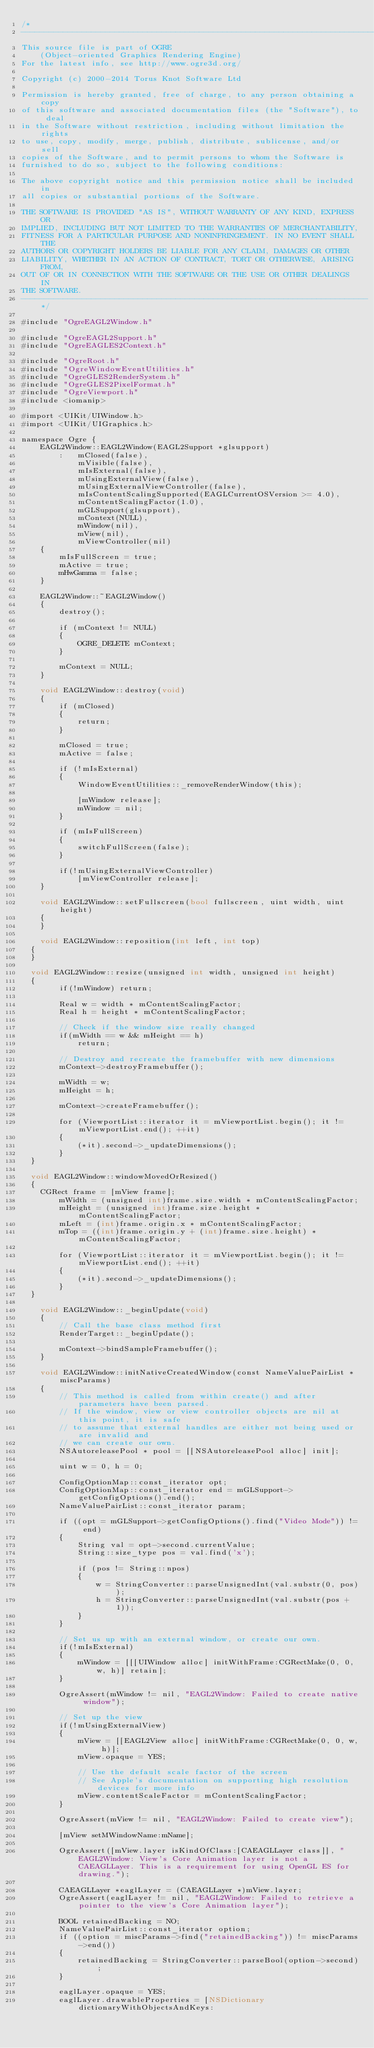Convert code to text. <code><loc_0><loc_0><loc_500><loc_500><_ObjectiveC_>/*
-----------------------------------------------------------------------------
This source file is part of OGRE
    (Object-oriented Graphics Rendering Engine)
For the latest info, see http://www.ogre3d.org/

Copyright (c) 2000-2014 Torus Knot Software Ltd

Permission is hereby granted, free of charge, to any person obtaining a copy
of this software and associated documentation files (the "Software"), to deal
in the Software without restriction, including without limitation the rights
to use, copy, modify, merge, publish, distribute, sublicense, and/or sell
copies of the Software, and to permit persons to whom the Software is
furnished to do so, subject to the following conditions:

The above copyright notice and this permission notice shall be included in
all copies or substantial portions of the Software.

THE SOFTWARE IS PROVIDED "AS IS", WITHOUT WARRANTY OF ANY KIND, EXPRESS OR
IMPLIED, INCLUDING BUT NOT LIMITED TO THE WARRANTIES OF MERCHANTABILITY,
FITNESS FOR A PARTICULAR PURPOSE AND NONINFRINGEMENT. IN NO EVENT SHALL THE
AUTHORS OR COPYRIGHT HOLDERS BE LIABLE FOR ANY CLAIM, DAMAGES OR OTHER
LIABILITY, WHETHER IN AN ACTION OF CONTRACT, TORT OR OTHERWISE, ARISING FROM,
OUT OF OR IN CONNECTION WITH THE SOFTWARE OR THE USE OR OTHER DEALINGS IN
THE SOFTWARE.
--------------------------------------------------------------------------*/

#include "OgreEAGL2Window.h"

#include "OgreEAGL2Support.h"
#include "OgreEAGLES2Context.h"

#include "OgreRoot.h"
#include "OgreWindowEventUtilities.h"
#include "OgreGLES2RenderSystem.h"
#include "OgreGLES2PixelFormat.h"
#include "OgreViewport.h"
#include <iomanip>

#import <UIKit/UIWindow.h>
#import <UIKit/UIGraphics.h>

namespace Ogre {
    EAGL2Window::EAGL2Window(EAGL2Support *glsupport)
        :   mClosed(false),
            mVisible(false),
            mIsExternal(false),
            mUsingExternalView(false),
            mUsingExternalViewController(false),
            mIsContentScalingSupported(EAGLCurrentOSVersion >= 4.0),
            mContentScalingFactor(1.0),
            mGLSupport(glsupport),
            mContext(NULL),
            mWindow(nil),
            mView(nil),
            mViewController(nil)
    {
        mIsFullScreen = true;
        mActive = true;
        mHwGamma = false;
    }

    EAGL2Window::~EAGL2Window()
    {
        destroy();

        if (mContext != NULL)
        {
            OGRE_DELETE mContext;
        }

        mContext = NULL;
    }

    void EAGL2Window::destroy(void)
    {
        if (mClosed)
        {
            return;
        }

        mClosed = true;
        mActive = false;

        if (!mIsExternal)
        {
            WindowEventUtilities::_removeRenderWindow(this);
        
            [mWindow release];
            mWindow = nil;
        }

        if (mIsFullScreen)
        {
            switchFullScreen(false);
        }

        if(!mUsingExternalViewController)
            [mViewController release];
    }

    void EAGL2Window::setFullscreen(bool fullscreen, uint width, uint height)
    {
    }

    void EAGL2Window::reposition(int left, int top)
	{
	}
    
	void EAGL2Window::resize(unsigned int width, unsigned int height)
	{
        if(!mWindow) return;

        Real w = width * mContentScalingFactor;
        Real h = height * mContentScalingFactor;

        // Check if the window size really changed
        if(mWidth == w && mHeight == h)
            return;
        
        // Destroy and recreate the framebuffer with new dimensions 
        mContext->destroyFramebuffer();
        
        mWidth = w;
        mHeight = h;
        
        mContext->createFramebuffer();

        for (ViewportList::iterator it = mViewportList.begin(); it != mViewportList.end(); ++it)
        {
            (*it).second->_updateDimensions();
        }
	}
    
	void EAGL2Window::windowMovedOrResized()
	{
		CGRect frame = [mView frame];
        mWidth = (unsigned int)frame.size.width * mContentScalingFactor;
        mHeight = (unsigned int)frame.size.height * mContentScalingFactor;
        mLeft = (int)frame.origin.x * mContentScalingFactor;
        mTop = ((int)frame.origin.y + (int)frame.size.height) * mContentScalingFactor;

        for (ViewportList::iterator it = mViewportList.begin(); it != mViewportList.end(); ++it)
        {
            (*it).second->_updateDimensions();
        }
	}

    void EAGL2Window::_beginUpdate(void)
    {
        // Call the base class method first
        RenderTarget::_beginUpdate();

        mContext->bindSampleFramebuffer();
    }

    void EAGL2Window::initNativeCreatedWindow(const NameValuePairList *miscParams)
    {
        // This method is called from within create() and after parameters have been parsed.
        // If the window, view or view controller objects are nil at this point, it is safe
        // to assume that external handles are either not being used or are invalid and
        // we can create our own.
        NSAutoreleasePool * pool = [[NSAutoreleasePool alloc] init];
        
        uint w = 0, h = 0;
        
        ConfigOptionMap::const_iterator opt;
        ConfigOptionMap::const_iterator end = mGLSupport->getConfigOptions().end();
        NameValuePairList::const_iterator param;

        if ((opt = mGLSupport->getConfigOptions().find("Video Mode")) != end)
        {
            String val = opt->second.currentValue;
            String::size_type pos = val.find('x');
            
            if (pos != String::npos)
            {
                w = StringConverter::parseUnsignedInt(val.substr(0, pos));
                h = StringConverter::parseUnsignedInt(val.substr(pos + 1));
            }
        }

        // Set us up with an external window, or create our own.
        if(!mIsExternal)
        {
            mWindow = [[[UIWindow alloc] initWithFrame:CGRectMake(0, 0, w, h)] retain];
        }
        
        OgreAssert(mWindow != nil, "EAGL2Window: Failed to create native window");
        
        // Set up the view
        if(!mUsingExternalView)
        {
            mView = [[EAGL2View alloc] initWithFrame:CGRectMake(0, 0, w, h)];
            mView.opaque = YES;

            // Use the default scale factor of the screen
            // See Apple's documentation on supporting high resolution devices for more info
            mView.contentScaleFactor = mContentScalingFactor;
        }
    
        OgreAssert(mView != nil, "EAGL2Window: Failed to create view");
        
        [mView setMWindowName:mName];

        OgreAssert([mView.layer isKindOfClass:[CAEAGLLayer class]], "EAGL2Window: View's Core Animation layer is not a CAEAGLLayer. This is a requirement for using OpenGL ES for drawing.");
        
        CAEAGLLayer *eaglLayer = (CAEAGLLayer *)mView.layer;
        OgreAssert(eaglLayer != nil, "EAGL2Window: Failed to retrieve a pointer to the view's Core Animation layer");

        BOOL retainedBacking = NO;
        NameValuePairList::const_iterator option;
        if ((option = miscParams->find("retainedBacking")) != miscParams->end())
        {
            retainedBacking = StringConverter::parseBool(option->second);
        }

        eaglLayer.opaque = YES;
        eaglLayer.drawableProperties = [NSDictionary dictionaryWithObjectsAndKeys:</code> 